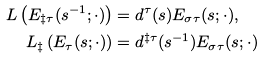<formula> <loc_0><loc_0><loc_500><loc_500>L \left ( E _ { \ddagger \tau } ( s ^ { - 1 } ; \cdot ) \right ) & = d ^ { \tau } ( s ) E _ { \sigma \tau } ( s ; \cdot ) , \\ L _ { \ddagger } \left ( E _ { \tau } ( s ; \cdot ) \right ) & = d ^ { \ddagger \tau } ( s ^ { - 1 } ) E _ { \sigma \tau } ( s ; \cdot )</formula> 